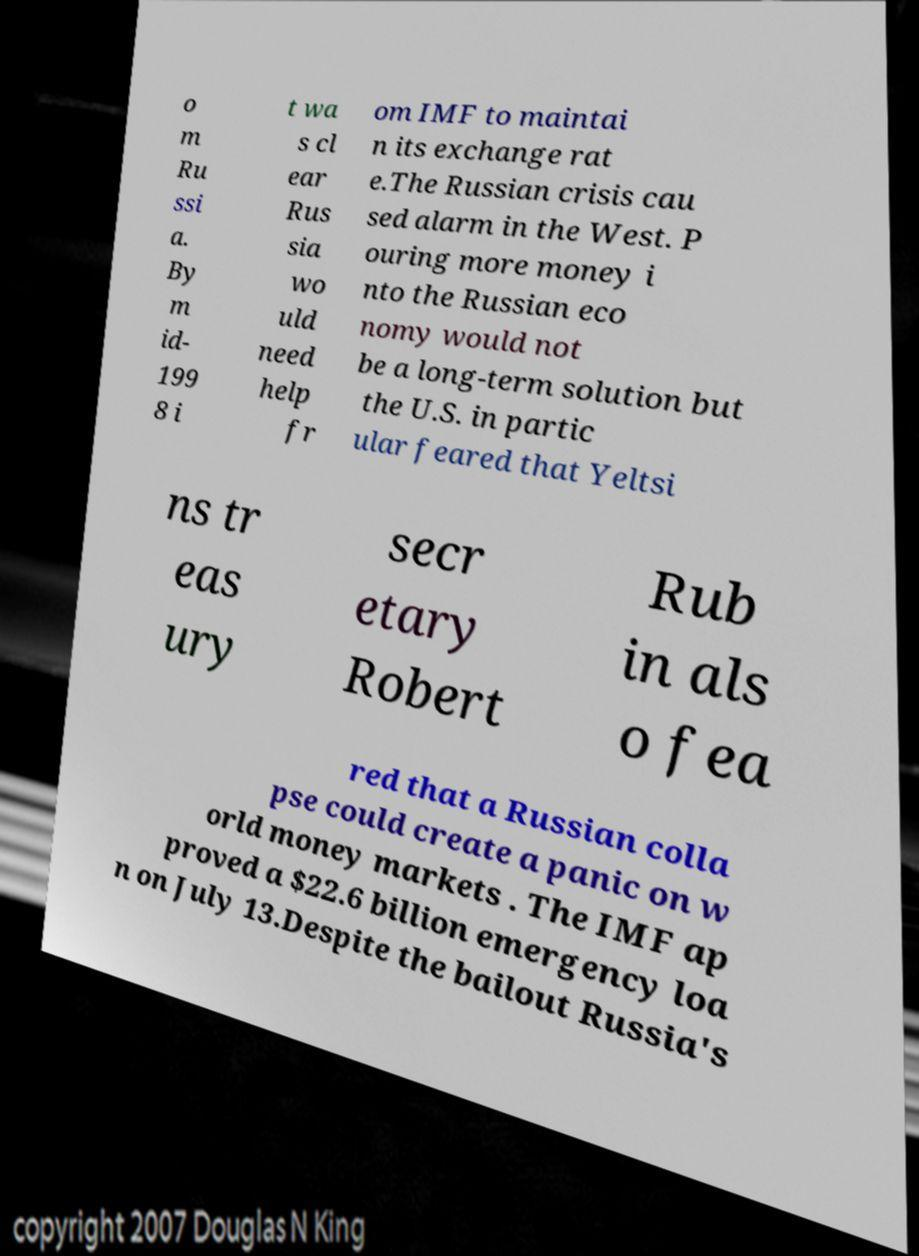Please identify and transcribe the text found in this image. o m Ru ssi a. By m id- 199 8 i t wa s cl ear Rus sia wo uld need help fr om IMF to maintai n its exchange rat e.The Russian crisis cau sed alarm in the West. P ouring more money i nto the Russian eco nomy would not be a long-term solution but the U.S. in partic ular feared that Yeltsi ns tr eas ury secr etary Robert Rub in als o fea red that a Russian colla pse could create a panic on w orld money markets . The IMF ap proved a $22.6 billion emergency loa n on July 13.Despite the bailout Russia's 